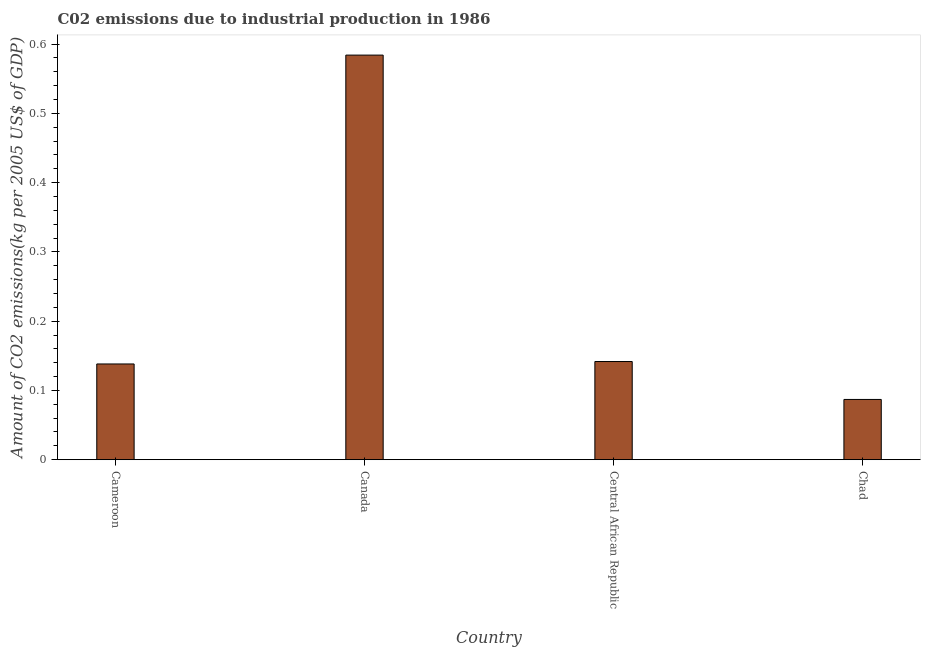What is the title of the graph?
Your answer should be compact. C02 emissions due to industrial production in 1986. What is the label or title of the Y-axis?
Your answer should be very brief. Amount of CO2 emissions(kg per 2005 US$ of GDP). What is the amount of co2 emissions in Canada?
Provide a short and direct response. 0.58. Across all countries, what is the maximum amount of co2 emissions?
Offer a terse response. 0.58. Across all countries, what is the minimum amount of co2 emissions?
Offer a terse response. 0.09. In which country was the amount of co2 emissions maximum?
Your response must be concise. Canada. In which country was the amount of co2 emissions minimum?
Your answer should be compact. Chad. What is the sum of the amount of co2 emissions?
Your answer should be compact. 0.95. What is the difference between the amount of co2 emissions in Cameroon and Canada?
Offer a terse response. -0.45. What is the average amount of co2 emissions per country?
Offer a terse response. 0.24. What is the median amount of co2 emissions?
Keep it short and to the point. 0.14. In how many countries, is the amount of co2 emissions greater than 0.46 kg per 2005 US$ of GDP?
Your answer should be compact. 1. What is the ratio of the amount of co2 emissions in Central African Republic to that in Chad?
Offer a terse response. 1.63. Is the amount of co2 emissions in Canada less than that in Chad?
Ensure brevity in your answer.  No. Is the difference between the amount of co2 emissions in Cameroon and Central African Republic greater than the difference between any two countries?
Your response must be concise. No. What is the difference between the highest and the second highest amount of co2 emissions?
Make the answer very short. 0.44. Is the sum of the amount of co2 emissions in Central African Republic and Chad greater than the maximum amount of co2 emissions across all countries?
Make the answer very short. No. What is the difference between the highest and the lowest amount of co2 emissions?
Your answer should be compact. 0.5. How many countries are there in the graph?
Your answer should be compact. 4. What is the difference between two consecutive major ticks on the Y-axis?
Ensure brevity in your answer.  0.1. What is the Amount of CO2 emissions(kg per 2005 US$ of GDP) of Cameroon?
Your answer should be very brief. 0.14. What is the Amount of CO2 emissions(kg per 2005 US$ of GDP) in Canada?
Give a very brief answer. 0.58. What is the Amount of CO2 emissions(kg per 2005 US$ of GDP) in Central African Republic?
Give a very brief answer. 0.14. What is the Amount of CO2 emissions(kg per 2005 US$ of GDP) in Chad?
Your response must be concise. 0.09. What is the difference between the Amount of CO2 emissions(kg per 2005 US$ of GDP) in Cameroon and Canada?
Offer a very short reply. -0.45. What is the difference between the Amount of CO2 emissions(kg per 2005 US$ of GDP) in Cameroon and Central African Republic?
Your answer should be compact. -0. What is the difference between the Amount of CO2 emissions(kg per 2005 US$ of GDP) in Cameroon and Chad?
Your answer should be compact. 0.05. What is the difference between the Amount of CO2 emissions(kg per 2005 US$ of GDP) in Canada and Central African Republic?
Your response must be concise. 0.44. What is the difference between the Amount of CO2 emissions(kg per 2005 US$ of GDP) in Canada and Chad?
Make the answer very short. 0.5. What is the difference between the Amount of CO2 emissions(kg per 2005 US$ of GDP) in Central African Republic and Chad?
Give a very brief answer. 0.05. What is the ratio of the Amount of CO2 emissions(kg per 2005 US$ of GDP) in Cameroon to that in Canada?
Make the answer very short. 0.24. What is the ratio of the Amount of CO2 emissions(kg per 2005 US$ of GDP) in Cameroon to that in Chad?
Offer a terse response. 1.59. What is the ratio of the Amount of CO2 emissions(kg per 2005 US$ of GDP) in Canada to that in Central African Republic?
Offer a terse response. 4.12. What is the ratio of the Amount of CO2 emissions(kg per 2005 US$ of GDP) in Canada to that in Chad?
Your answer should be very brief. 6.71. What is the ratio of the Amount of CO2 emissions(kg per 2005 US$ of GDP) in Central African Republic to that in Chad?
Provide a short and direct response. 1.63. 